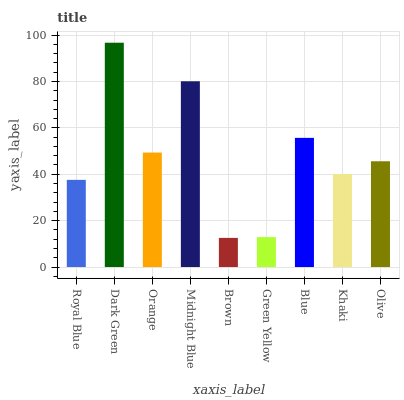Is Orange the minimum?
Answer yes or no. No. Is Orange the maximum?
Answer yes or no. No. Is Dark Green greater than Orange?
Answer yes or no. Yes. Is Orange less than Dark Green?
Answer yes or no. Yes. Is Orange greater than Dark Green?
Answer yes or no. No. Is Dark Green less than Orange?
Answer yes or no. No. Is Olive the high median?
Answer yes or no. Yes. Is Olive the low median?
Answer yes or no. Yes. Is Midnight Blue the high median?
Answer yes or no. No. Is Orange the low median?
Answer yes or no. No. 